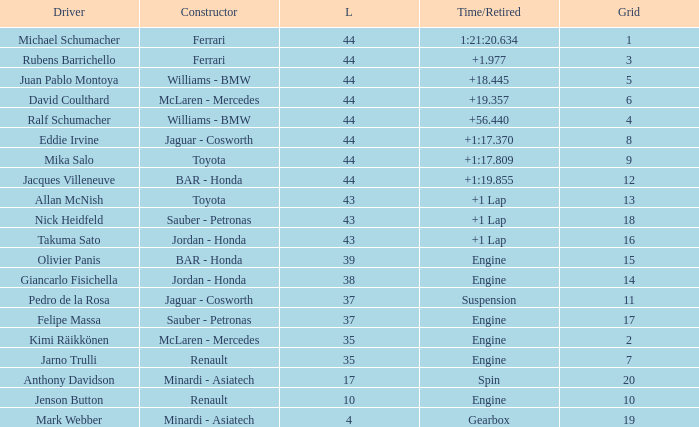What was the fewest laps for somone who finished +18.445? 44.0. 